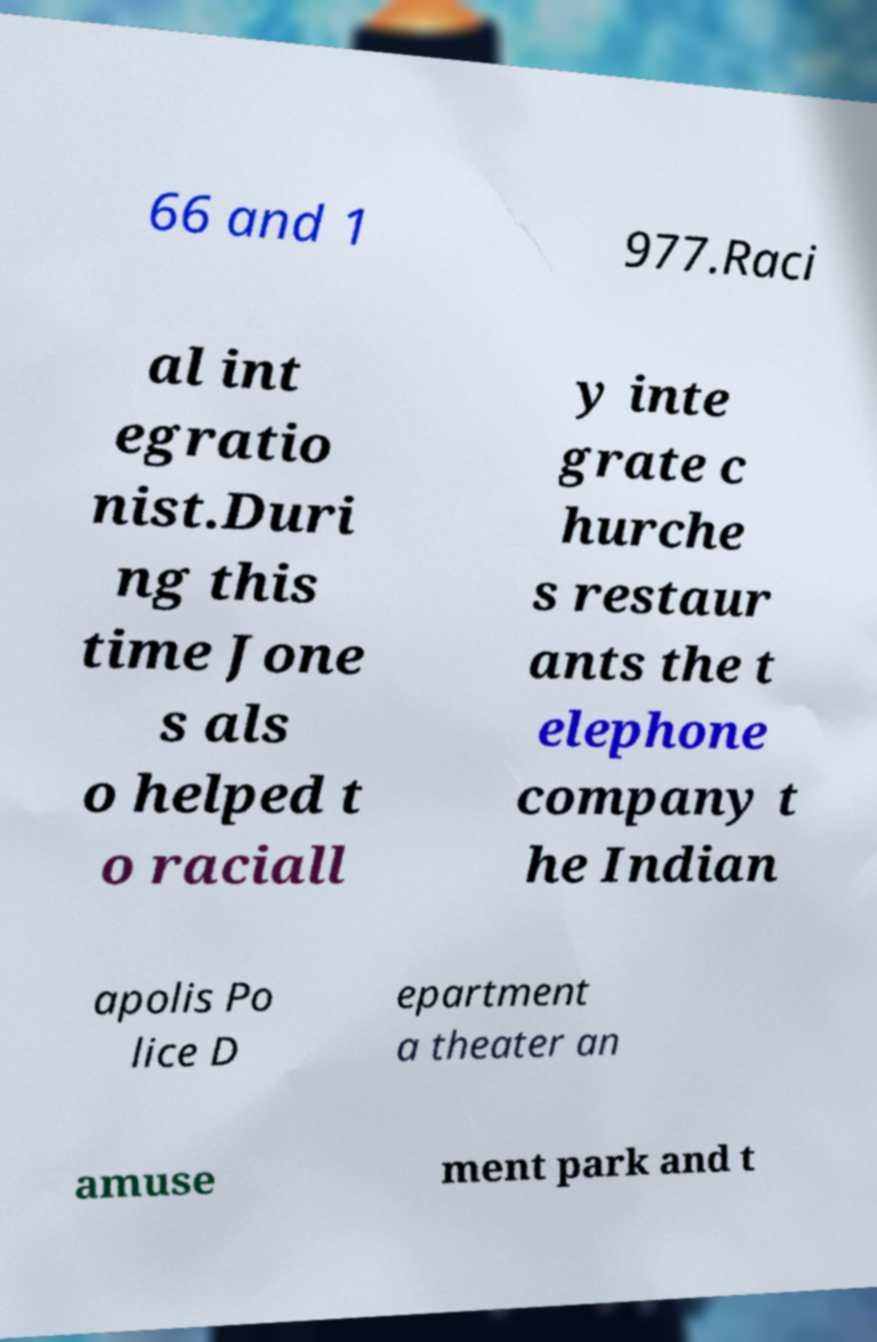What messages or text are displayed in this image? I need them in a readable, typed format. 66 and 1 977.Raci al int egratio nist.Duri ng this time Jone s als o helped t o raciall y inte grate c hurche s restaur ants the t elephone company t he Indian apolis Po lice D epartment a theater an amuse ment park and t 